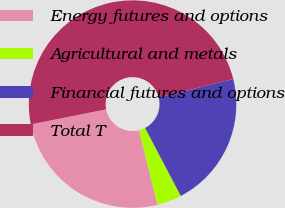Convert chart to OTSL. <chart><loc_0><loc_0><loc_500><loc_500><pie_chart><fcel>Energy futures and options<fcel>Agricultural and metals<fcel>Financial futures and options<fcel>Total T<nl><fcel>25.73%<fcel>3.83%<fcel>21.19%<fcel>49.25%<nl></chart> 